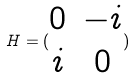Convert formula to latex. <formula><loc_0><loc_0><loc_500><loc_500>H = ( \begin{matrix} 0 & - i \\ i & 0 \end{matrix} )</formula> 